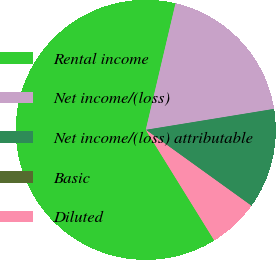Convert chart. <chart><loc_0><loc_0><loc_500><loc_500><pie_chart><fcel>Rental income<fcel>Net income/(loss)<fcel>Net income/(loss) attributable<fcel>Basic<fcel>Diluted<nl><fcel>62.5%<fcel>18.75%<fcel>12.5%<fcel>0.0%<fcel>6.25%<nl></chart> 